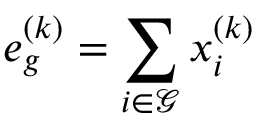<formula> <loc_0><loc_0><loc_500><loc_500>e _ { g } ^ { ( k ) } = \sum _ { i \in \mathcal { G } } x _ { i } ^ { ( k ) }</formula> 